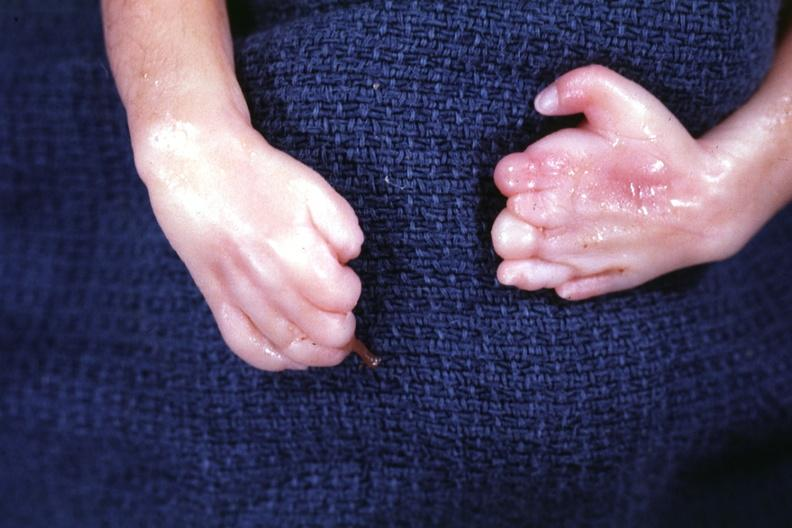what is present?
Answer the question using a single word or phrase. Dysplastic 